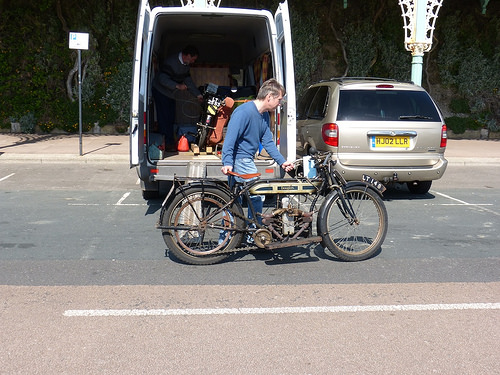<image>
Is the bike behind the car? Yes. From this viewpoint, the bike is positioned behind the car, with the car partially or fully occluding the bike. Is there a van to the right of the bike? No. The van is not to the right of the bike. The horizontal positioning shows a different relationship. 